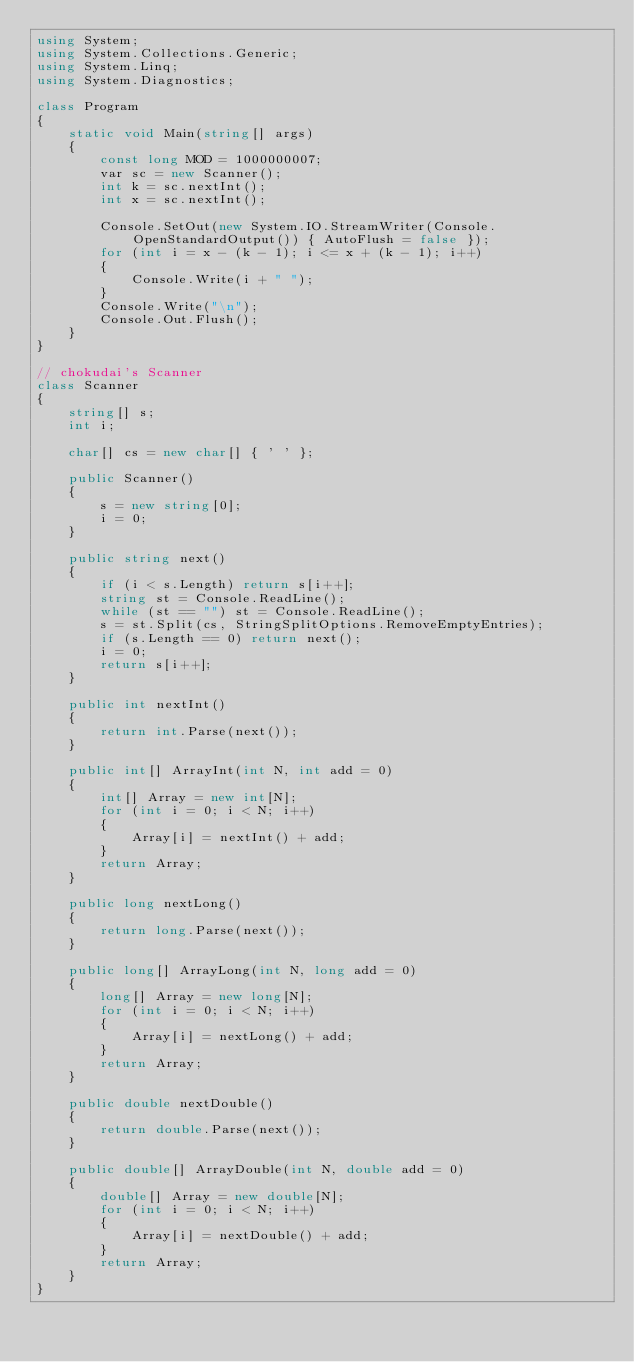Convert code to text. <code><loc_0><loc_0><loc_500><loc_500><_C#_>using System;
using System.Collections.Generic;
using System.Linq;
using System.Diagnostics;

class Program
{
    static void Main(string[] args)
    {
        const long MOD = 1000000007;
        var sc = new Scanner();
        int k = sc.nextInt();
        int x = sc.nextInt();

        Console.SetOut(new System.IO.StreamWriter(Console.OpenStandardOutput()) { AutoFlush = false });
        for (int i = x - (k - 1); i <= x + (k - 1); i++)
        {
            Console.Write(i + " ");
        }
        Console.Write("\n");
        Console.Out.Flush();
    }
}

// chokudai's Scanner
class Scanner
{
    string[] s;
    int i;

    char[] cs = new char[] { ' ' };

    public Scanner()
    {
        s = new string[0];
        i = 0;
    }

    public string next()
    {
        if (i < s.Length) return s[i++];
        string st = Console.ReadLine();
        while (st == "") st = Console.ReadLine();
        s = st.Split(cs, StringSplitOptions.RemoveEmptyEntries);
        if (s.Length == 0) return next();
        i = 0;
        return s[i++];
    }

    public int nextInt()
    {
        return int.Parse(next());
    }

    public int[] ArrayInt(int N, int add = 0)
    {
        int[] Array = new int[N];
        for (int i = 0; i < N; i++)
        {
            Array[i] = nextInt() + add;
        }
        return Array;
    }

    public long nextLong()
    {
        return long.Parse(next());
    }

    public long[] ArrayLong(int N, long add = 0)
    {
        long[] Array = new long[N];
        for (int i = 0; i < N; i++)
        {
            Array[i] = nextLong() + add;
        }
        return Array;
    }

    public double nextDouble()
    {
        return double.Parse(next());
    }

    public double[] ArrayDouble(int N, double add = 0)
    {
        double[] Array = new double[N];
        for (int i = 0; i < N; i++)
        {
            Array[i] = nextDouble() + add;
        }
        return Array;
    }
}</code> 